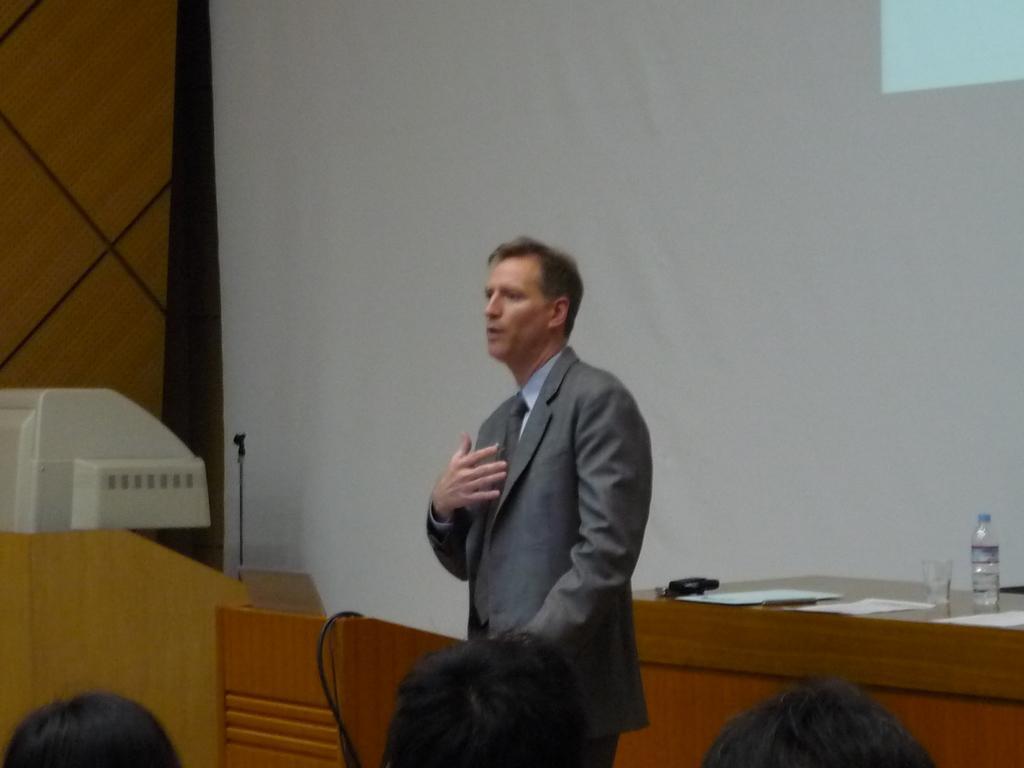In one or two sentences, can you explain what this image depicts? In this image a person is standing. Bottom of the image there are few persons. Left side there is an object. Before it there is a podium. Right side there is a table having few papers, bottle, glass and few objects on it. Background there is a wall. 